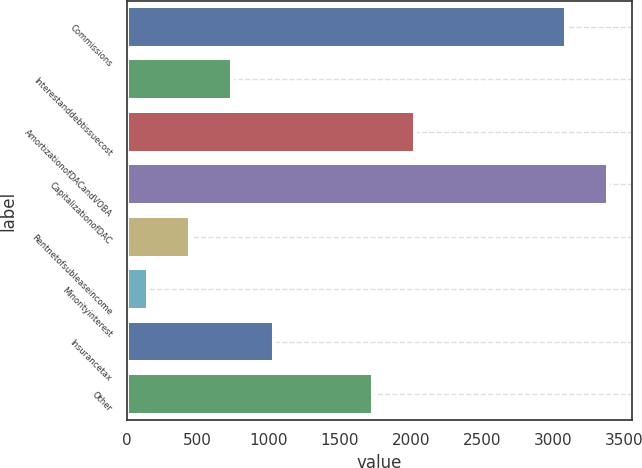Convert chart to OTSL. <chart><loc_0><loc_0><loc_500><loc_500><bar_chart><fcel>Commissions<fcel>Interestanddebtissuecost<fcel>AmortizationofDACandVOBA<fcel>CapitalizationofDAC<fcel>Rentnetofsubleaseincome<fcel>Minorityinterest<fcel>Insurancetax<fcel>Other<nl><fcel>3090<fcel>741.8<fcel>2028.9<fcel>3384.9<fcel>446.9<fcel>152<fcel>1036.7<fcel>1734<nl></chart> 